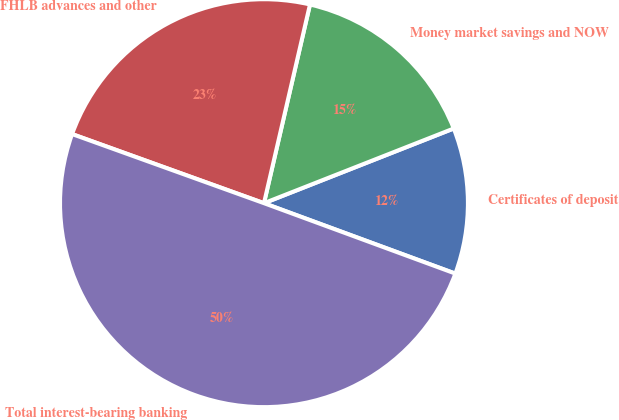Convert chart. <chart><loc_0><loc_0><loc_500><loc_500><pie_chart><fcel>Certificates of deposit<fcel>Money market savings and NOW<fcel>FHLB advances and other<fcel>Total interest-bearing banking<nl><fcel>11.58%<fcel>15.41%<fcel>23.12%<fcel>49.89%<nl></chart> 